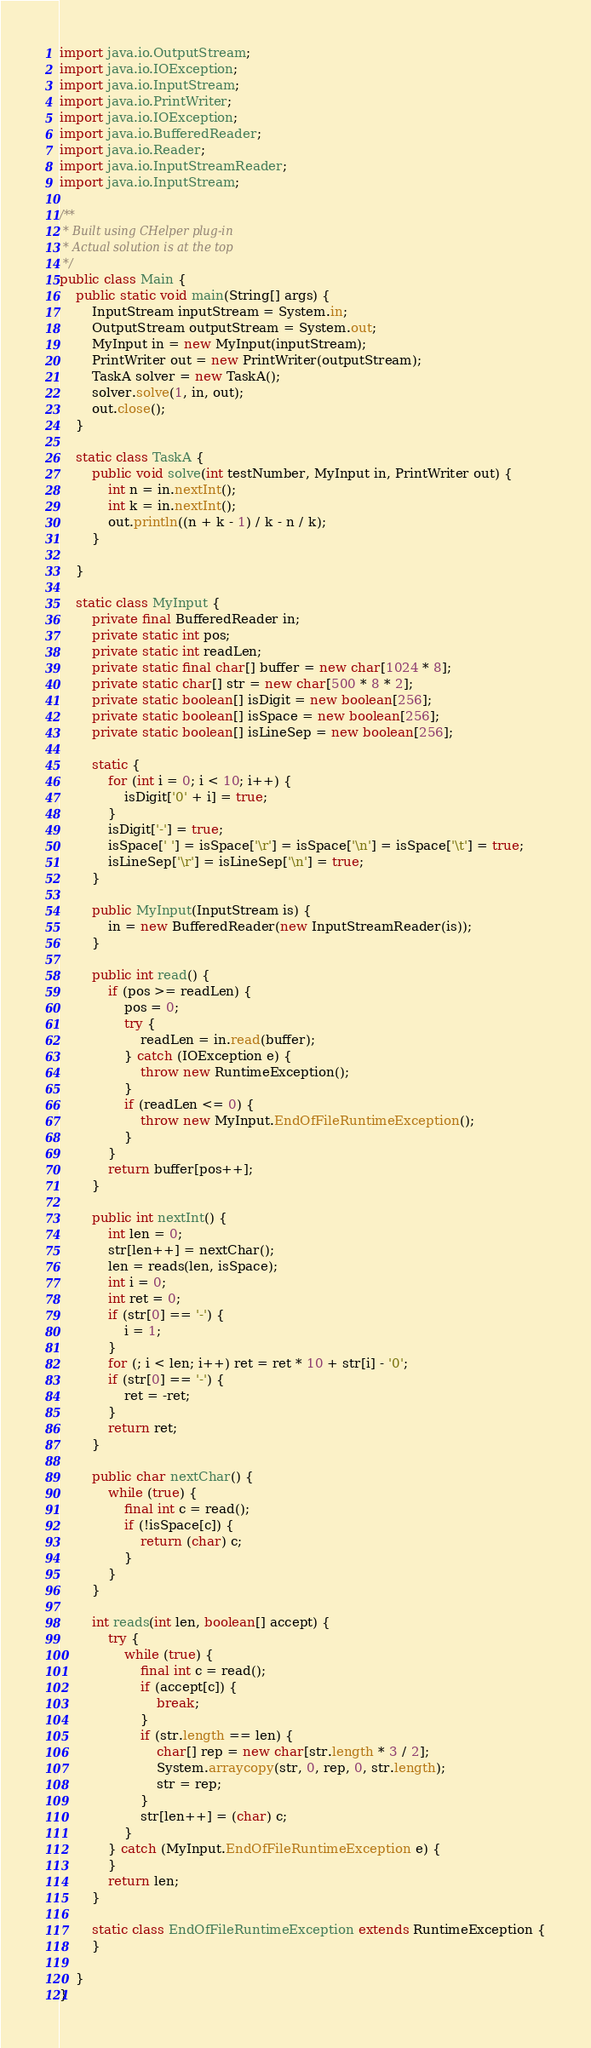Convert code to text. <code><loc_0><loc_0><loc_500><loc_500><_Java_>import java.io.OutputStream;
import java.io.IOException;
import java.io.InputStream;
import java.io.PrintWriter;
import java.io.IOException;
import java.io.BufferedReader;
import java.io.Reader;
import java.io.InputStreamReader;
import java.io.InputStream;

/**
 * Built using CHelper plug-in
 * Actual solution is at the top
 */
public class Main {
    public static void main(String[] args) {
        InputStream inputStream = System.in;
        OutputStream outputStream = System.out;
        MyInput in = new MyInput(inputStream);
        PrintWriter out = new PrintWriter(outputStream);
        TaskA solver = new TaskA();
        solver.solve(1, in, out);
        out.close();
    }

    static class TaskA {
        public void solve(int testNumber, MyInput in, PrintWriter out) {
            int n = in.nextInt();
            int k = in.nextInt();
            out.println((n + k - 1) / k - n / k);
        }

    }

    static class MyInput {
        private final BufferedReader in;
        private static int pos;
        private static int readLen;
        private static final char[] buffer = new char[1024 * 8];
        private static char[] str = new char[500 * 8 * 2];
        private static boolean[] isDigit = new boolean[256];
        private static boolean[] isSpace = new boolean[256];
        private static boolean[] isLineSep = new boolean[256];

        static {
            for (int i = 0; i < 10; i++) {
                isDigit['0' + i] = true;
            }
            isDigit['-'] = true;
            isSpace[' '] = isSpace['\r'] = isSpace['\n'] = isSpace['\t'] = true;
            isLineSep['\r'] = isLineSep['\n'] = true;
        }

        public MyInput(InputStream is) {
            in = new BufferedReader(new InputStreamReader(is));
        }

        public int read() {
            if (pos >= readLen) {
                pos = 0;
                try {
                    readLen = in.read(buffer);
                } catch (IOException e) {
                    throw new RuntimeException();
                }
                if (readLen <= 0) {
                    throw new MyInput.EndOfFileRuntimeException();
                }
            }
            return buffer[pos++];
        }

        public int nextInt() {
            int len = 0;
            str[len++] = nextChar();
            len = reads(len, isSpace);
            int i = 0;
            int ret = 0;
            if (str[0] == '-') {
                i = 1;
            }
            for (; i < len; i++) ret = ret * 10 + str[i] - '0';
            if (str[0] == '-') {
                ret = -ret;
            }
            return ret;
        }

        public char nextChar() {
            while (true) {
                final int c = read();
                if (!isSpace[c]) {
                    return (char) c;
                }
            }
        }

        int reads(int len, boolean[] accept) {
            try {
                while (true) {
                    final int c = read();
                    if (accept[c]) {
                        break;
                    }
                    if (str.length == len) {
                        char[] rep = new char[str.length * 3 / 2];
                        System.arraycopy(str, 0, rep, 0, str.length);
                        str = rep;
                    }
                    str[len++] = (char) c;
                }
            } catch (MyInput.EndOfFileRuntimeException e) {
            }
            return len;
        }

        static class EndOfFileRuntimeException extends RuntimeException {
        }

    }
}

</code> 